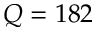Convert formula to latex. <formula><loc_0><loc_0><loc_500><loc_500>Q = 1 8 2</formula> 